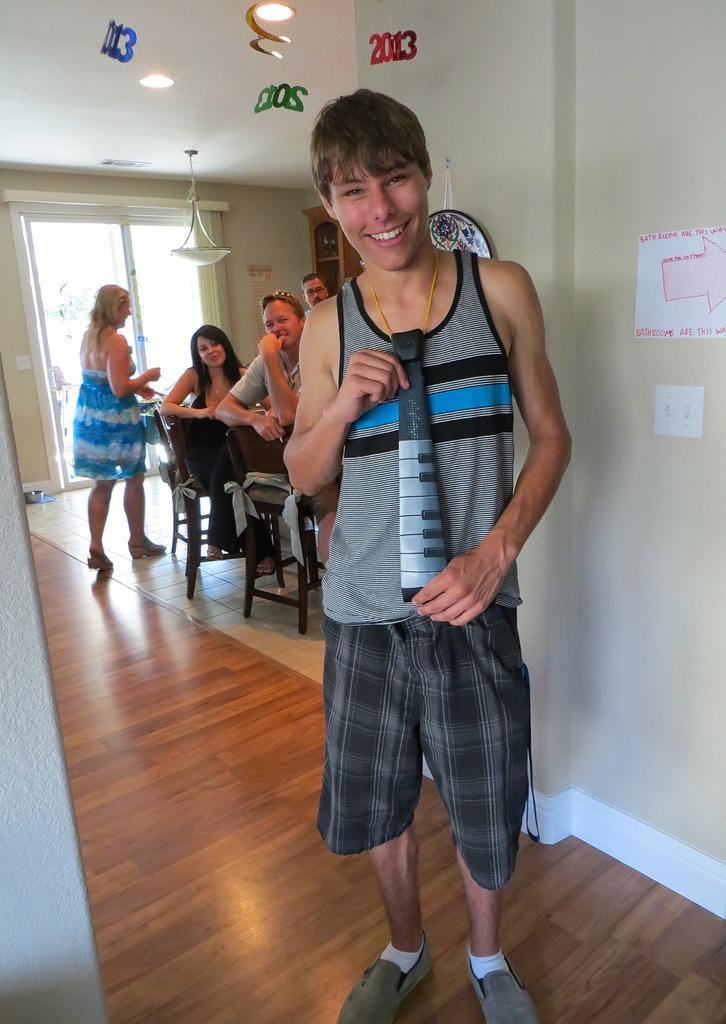Question: what does tie have?
Choices:
A. Piano keyboard design.
B. Purple stripes.
C. A paisley print.
D. A green insignia.
Answer with the letter. Answer: A Question: what has a hand-drawn arrow?
Choices:
A. Sign on wall.
B. The curb.
C. The picture.
D. The note pad.
Answer with the letter. Answer: A Question: how many people are in the picture?
Choices:
A. Four.
B. Three.
C. Five.
D. Two.
Answer with the letter. Answer: C Question: what design is on the tie?
Choices:
A. Flowers.
B. Stripes.
C. Piano keys.
D. A fishingrod.
Answer with the letter. Answer: C Question: what year is it, according to the decorations?
Choices:
A. 2091.
B. 2013.
C. 1992.
D. 1832.
Answer with the letter. Answer: B Question: what type of flooring is shown?
Choices:
A. Vinyl.
B. Hardwood.
C. Red flooring.
D. Broken flooring.
Answer with the letter. Answer: B Question: who is holding a tie?
Choices:
A. Young man.
B. The professor.
C. The politician.
D. The woman in red.
Answer with the letter. Answer: A Question: what is hanging above people?
Choices:
A. Telephone wires.
B. Clotheslines.
C. Red, blue and green 2013 signs.
D. Traffic lights.
Answer with the letter. Answer: C Question: what lets in sunshine?
Choices:
A. Open windows.
B. Drawn curtains.
C. Open blinds.
D. Patio doors.
Answer with the letter. Answer: D Question: who has plaid shorts on?
Choices:
A. The golfer.
B. Man with tie.
C. The waiter.
D. The hitchhiker.
Answer with the letter. Answer: B Question: how is the tie patterned?
Choices:
A. Like a piano.
B. Zigzag.
C. Circular.
D. Flowing.
Answer with the letter. Answer: A Question: how many women are there?
Choices:
A. Two.
B. Four.
C. Eight.
D. Ten.
Answer with the letter. Answer: A Question: who is wearing plaid shorts?
Choices:
A. A girl.
B. A lumberjack.
C. A smiling guy.
D. A hipster.
Answer with the letter. Answer: C Question: what is the man wearing?
Choices:
A. Plaid shorts.
B. A white shirt.
C. A black jacket.
D. A thing strapped tank top.
Answer with the letter. Answer: A 